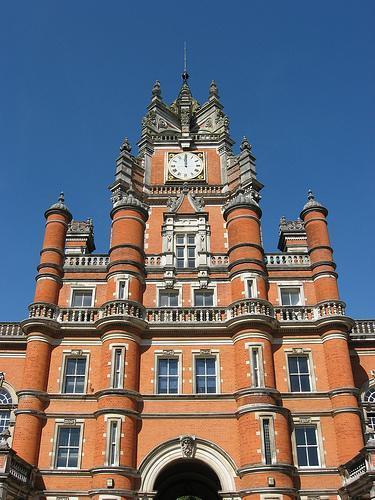How many clocks are in a given image?
Give a very brief answer. 1. 